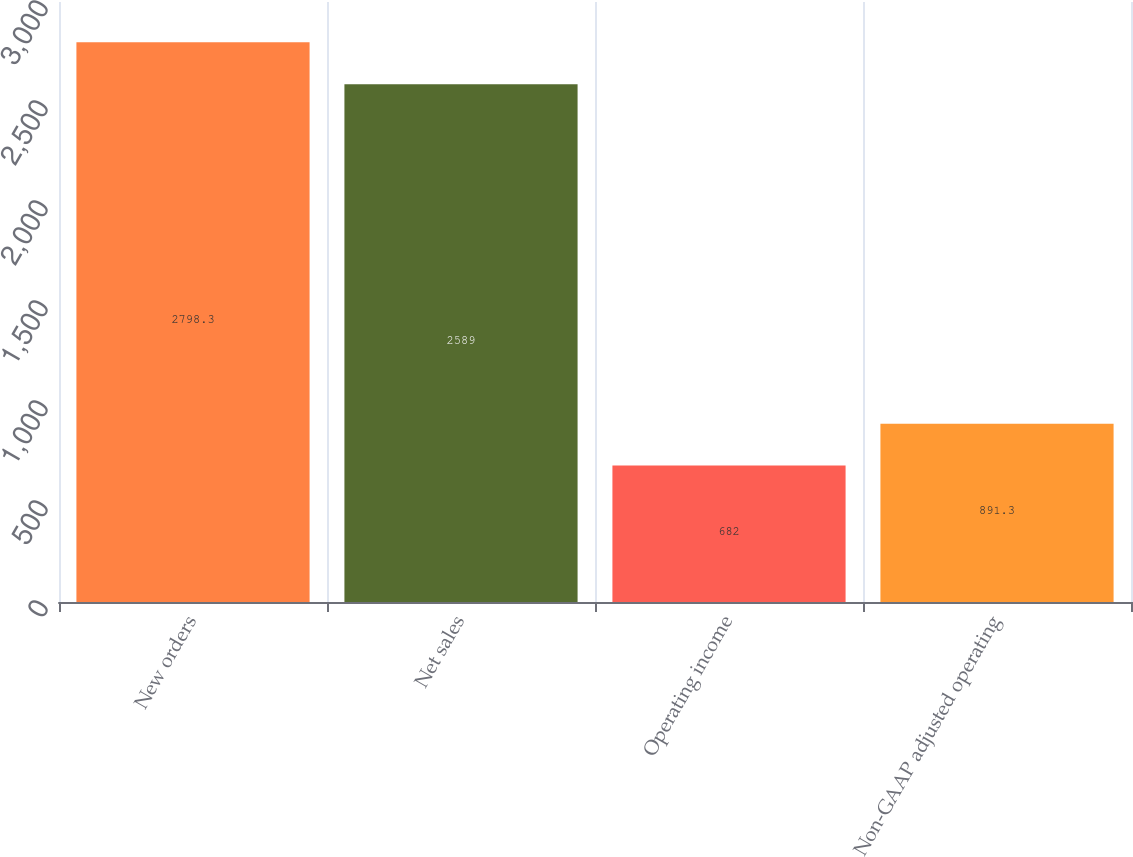Convert chart. <chart><loc_0><loc_0><loc_500><loc_500><bar_chart><fcel>New orders<fcel>Net sales<fcel>Operating income<fcel>Non-GAAP adjusted operating<nl><fcel>2798.3<fcel>2589<fcel>682<fcel>891.3<nl></chart> 